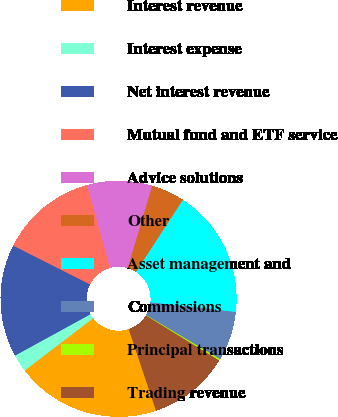Convert chart to OTSL. <chart><loc_0><loc_0><loc_500><loc_500><pie_chart><fcel>Interest revenue<fcel>Interest expense<fcel>Net interest revenue<fcel>Mutual fund and ETF service<fcel>Advice solutions<fcel>Other<fcel>Asset management and<fcel>Commissions<fcel>Principal transactions<fcel>Trading revenue<nl><fcel>19.78%<fcel>2.39%<fcel>15.43%<fcel>13.26%<fcel>8.91%<fcel>4.57%<fcel>17.61%<fcel>6.74%<fcel>0.22%<fcel>11.09%<nl></chart> 